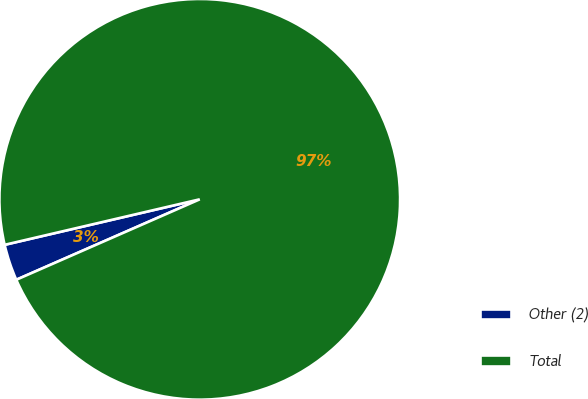Convert chart. <chart><loc_0><loc_0><loc_500><loc_500><pie_chart><fcel>Other (2)<fcel>Total<nl><fcel>2.93%<fcel>97.07%<nl></chart> 